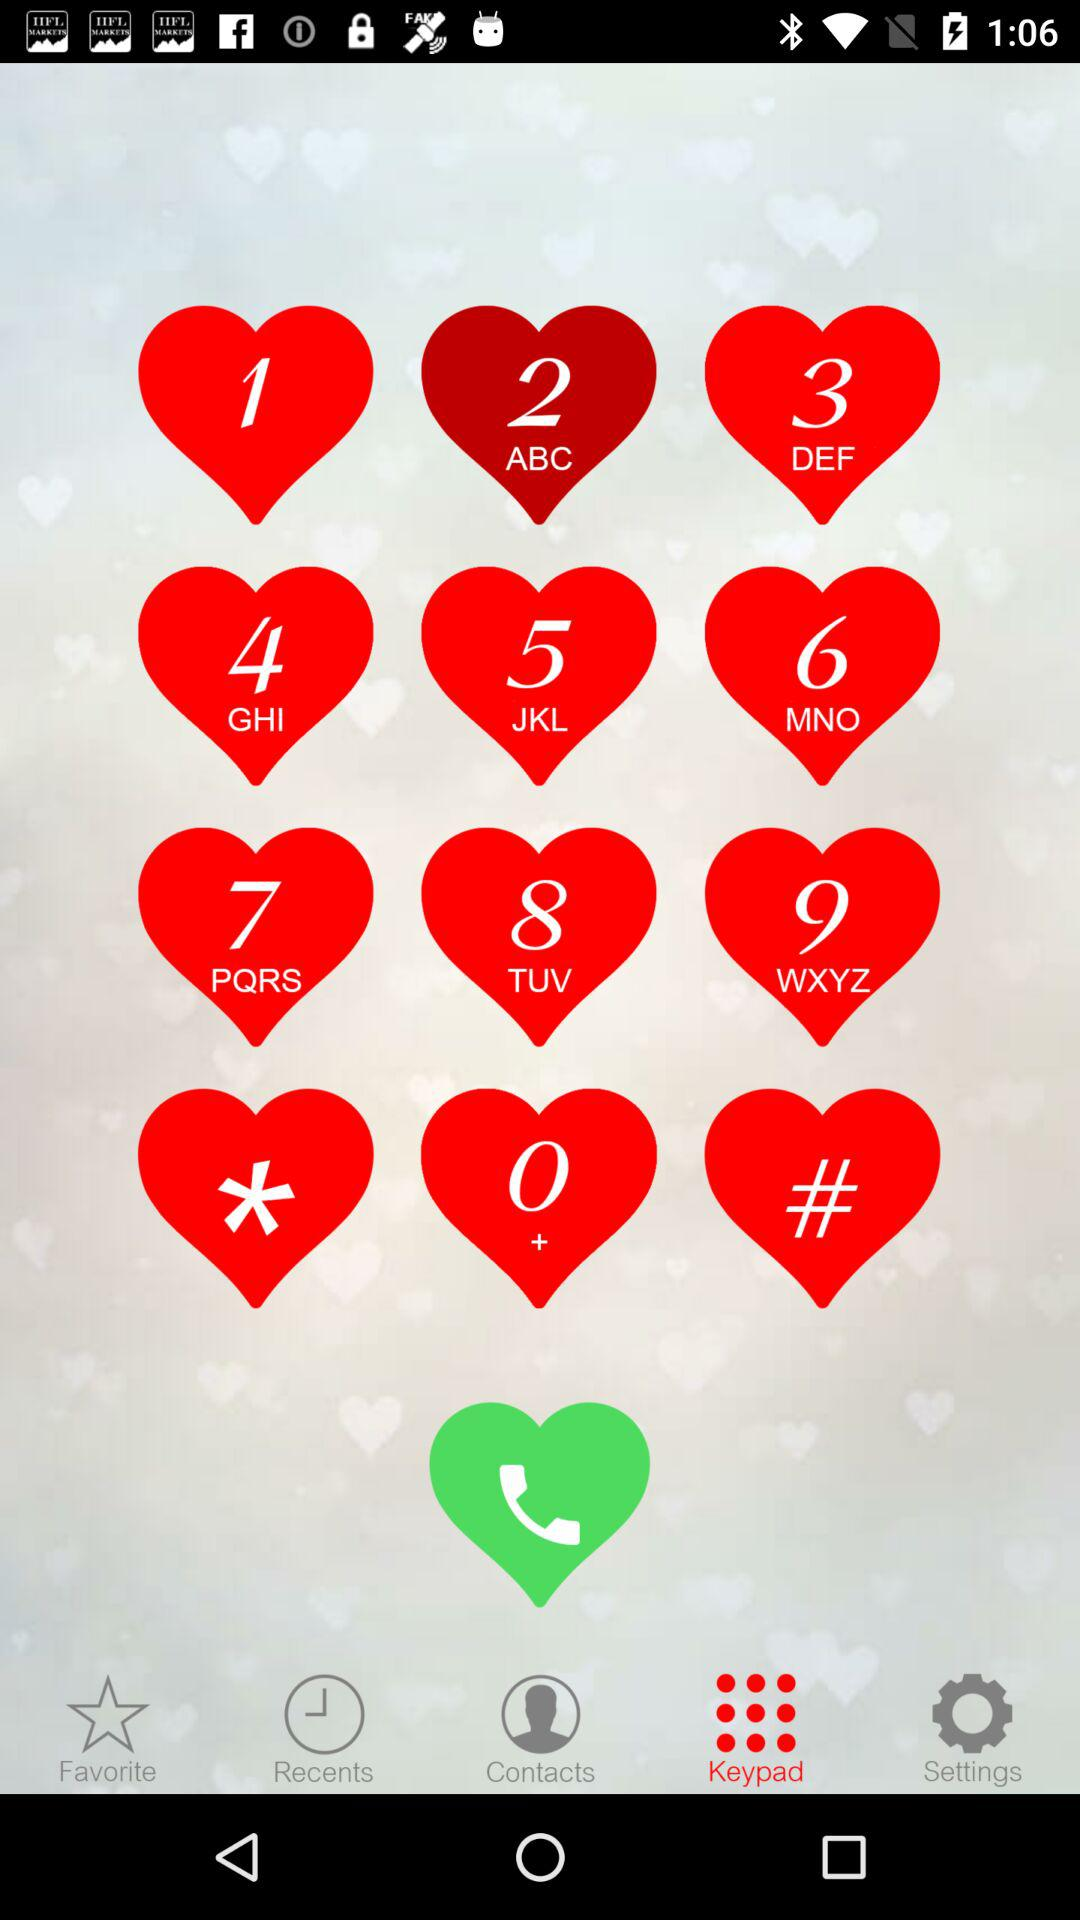How many notifications are there in "Settings"?
When the provided information is insufficient, respond with <no answer>. <no answer> 